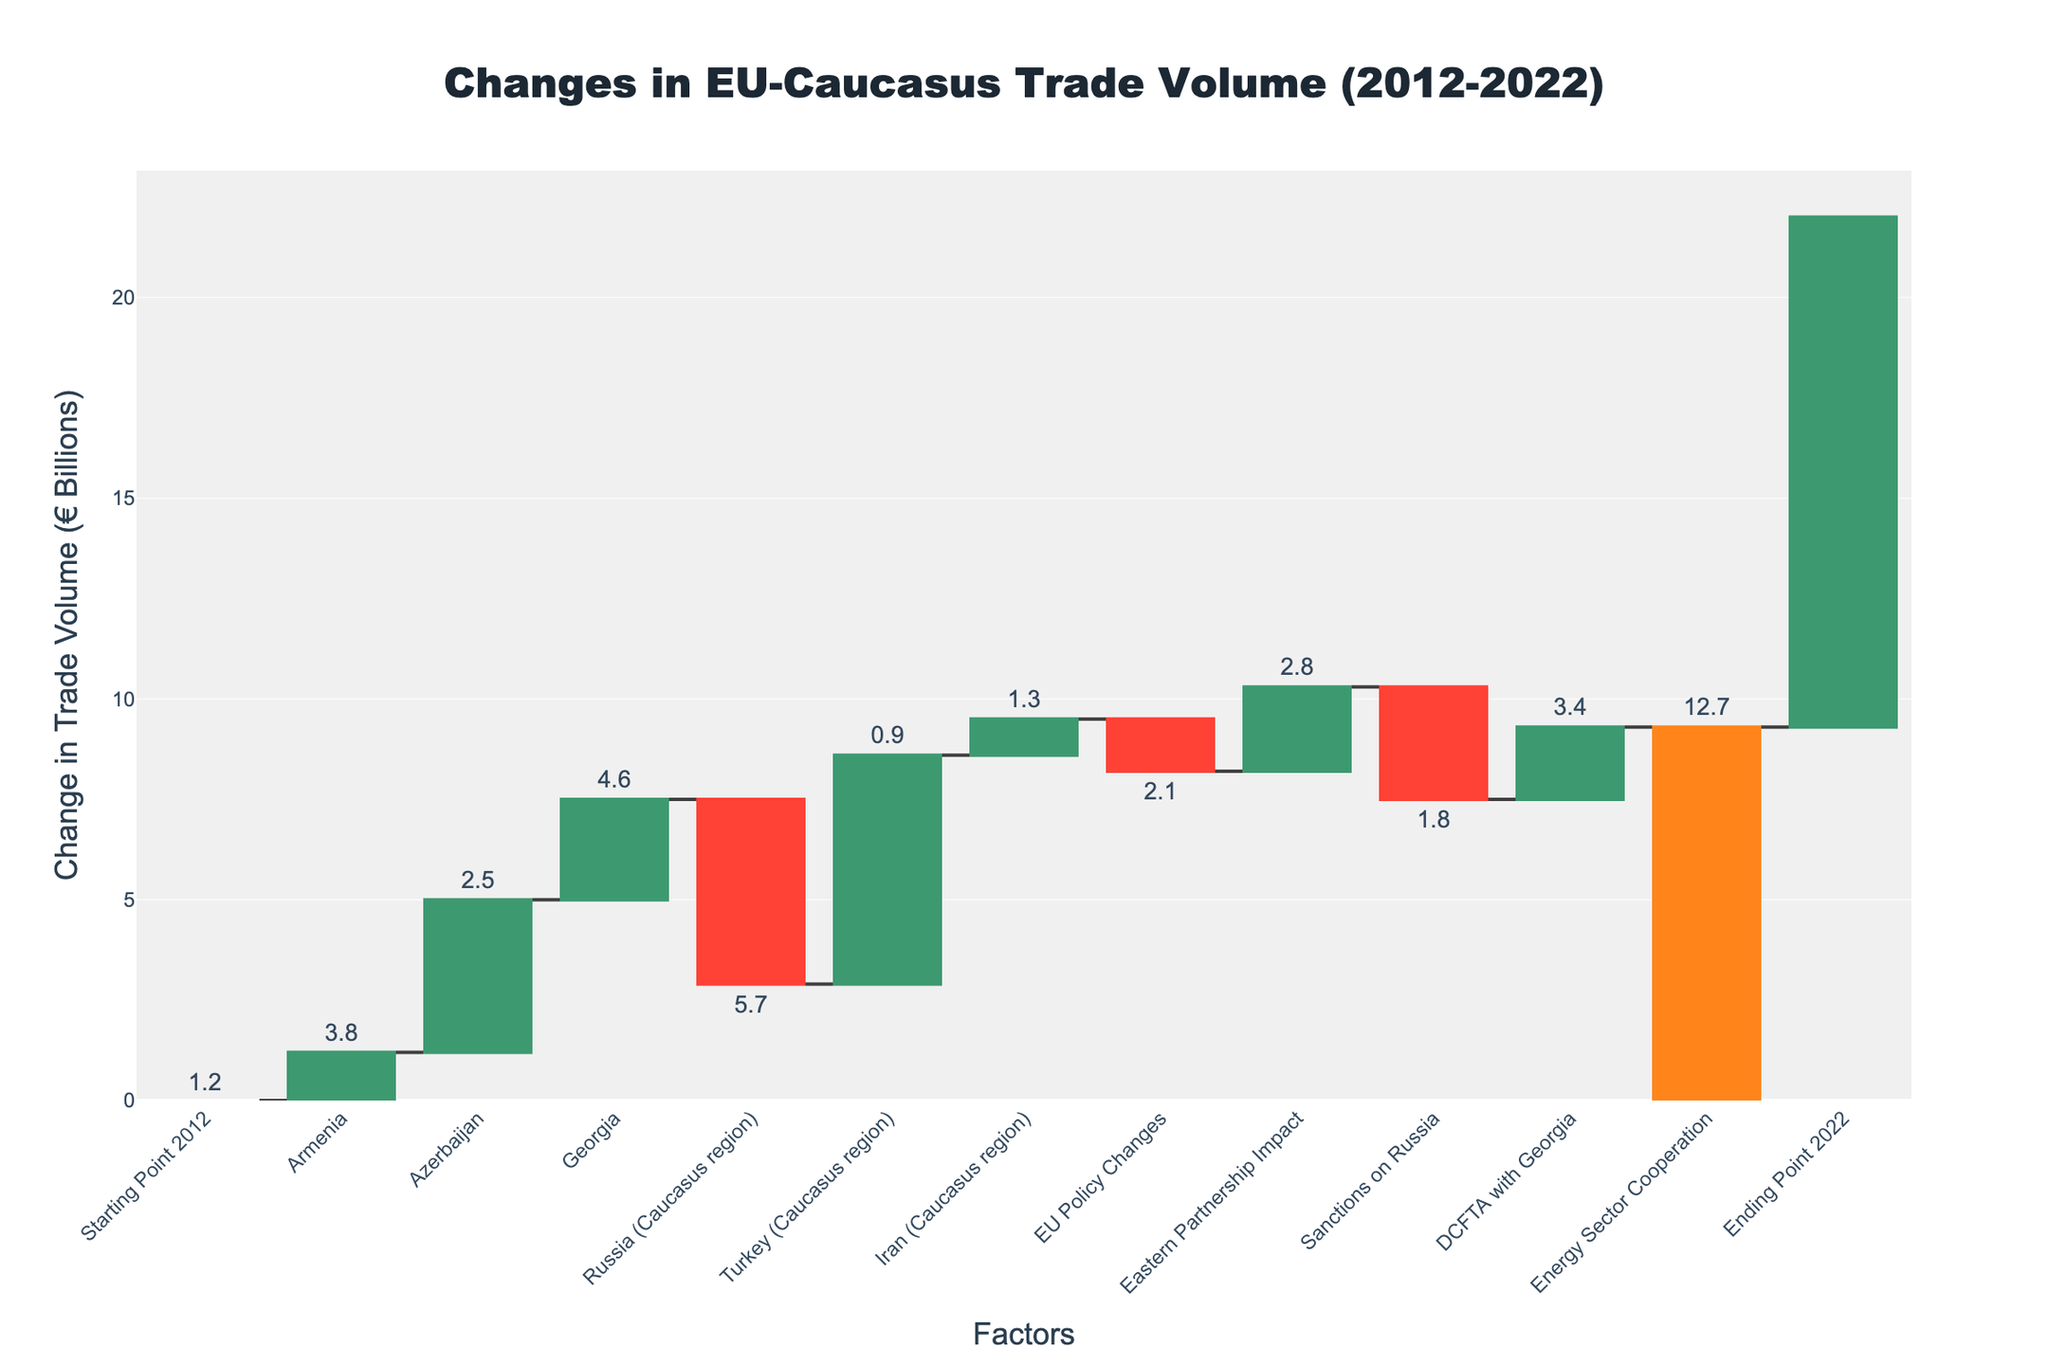What is the title of the chart? The chart title is located at the top of the figure. It states, "Changes in EU-Caucasus Trade Volume (2012-2022)."
Answer: Changes in EU-Caucasus Trade Volume (2012-2022) Which country has the highest positive change in trade volume? By observing the heights of the bars, Turkey (Caucasus region) shows the highest positive change as its bar rises the most compared to others.
Answer: Turkey (Caucasus region) What is the total change in trade volume from the starting point in 2012 to the ending point in 2022? The total change is depicted by the final bar labeled “Ending Point 2022,” which shows the cumulative result of all changes.
Answer: €12.7 Billion How did trade volume with Russia change over the past decade? The bar representing Russia (Caucasus region) shows a negative change, indicating a fall in trade volume. The value next to it is -€4.6 Billion.
Answer: -€4.6 Billion Sum the positive changes in trade volume contributed by Armenia, Azerbaijan, and Georgia. Armenia (+1.2), Azerbaijan (+3.8), and Georgia (+2.5) have positive contributions. Summing these values: \(1.2 + 3.8 + 2.5 = 7.5\)
Answer: €7.5 Billion What has a greater impact on the trade volume, sanctions on Russia or the DCFTA with Georgia? Compare the heights of the bars labeled "Sanctions on Russia" and "DCFTA with Georgia". Sanctions show a larger negative impact (-€2.8 Billion) compared to the positive impact of DCFTA (+€1.8 Billion).
Answer: Sanctions on Russia Which factor has contributed more to the increase in trade volume, EU Policy Changes or Energy Sector Cooperation? Check the height of the respective bars. Energy Sector Cooperation has a higher positive bar (+€3.4 Billion) compared to the negative bar of EU Policy Changes (-€1.3 Billion).
Answer: Energy Sector Cooperation Calculate the net effect of the Eastern Partnership Impact and Sanctions on Russia. Eastern Partnership Impact (+2.1 Billion) and Sanctions on Russia (-2.8 Billion). The net effect is \(2.1 - 2.8 = -0.7\) Billion.
Answer: -€0.7 Billion What is the average change in trade volumes for Armenia, Azerbaijan, and Georgia? The changes are: Armenia (+1.2), Azerbaijan (+3.8), and Georgia (+2.5). Average = \((1.2 + 3.8 + 2.5)/3 = 2.5\).
Answer: €2.5 Billion 